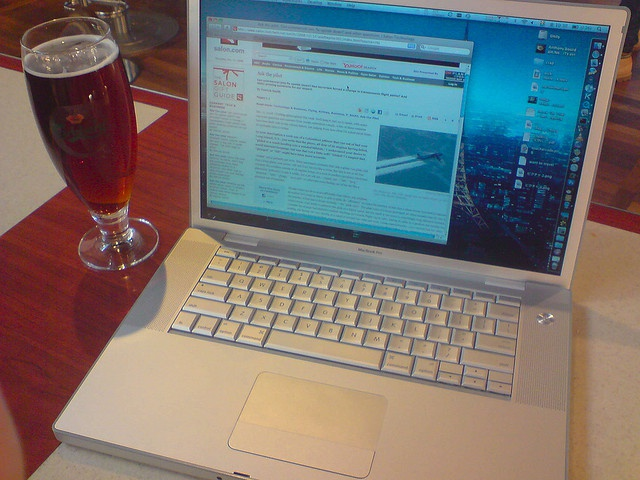Describe the objects in this image and their specific colors. I can see laptop in maroon, tan, teal, and darkgray tones, keyboard in maroon, tan, darkgray, and gray tones, dining table in maroon, brown, gray, and purple tones, and wine glass in maroon, black, and gray tones in this image. 